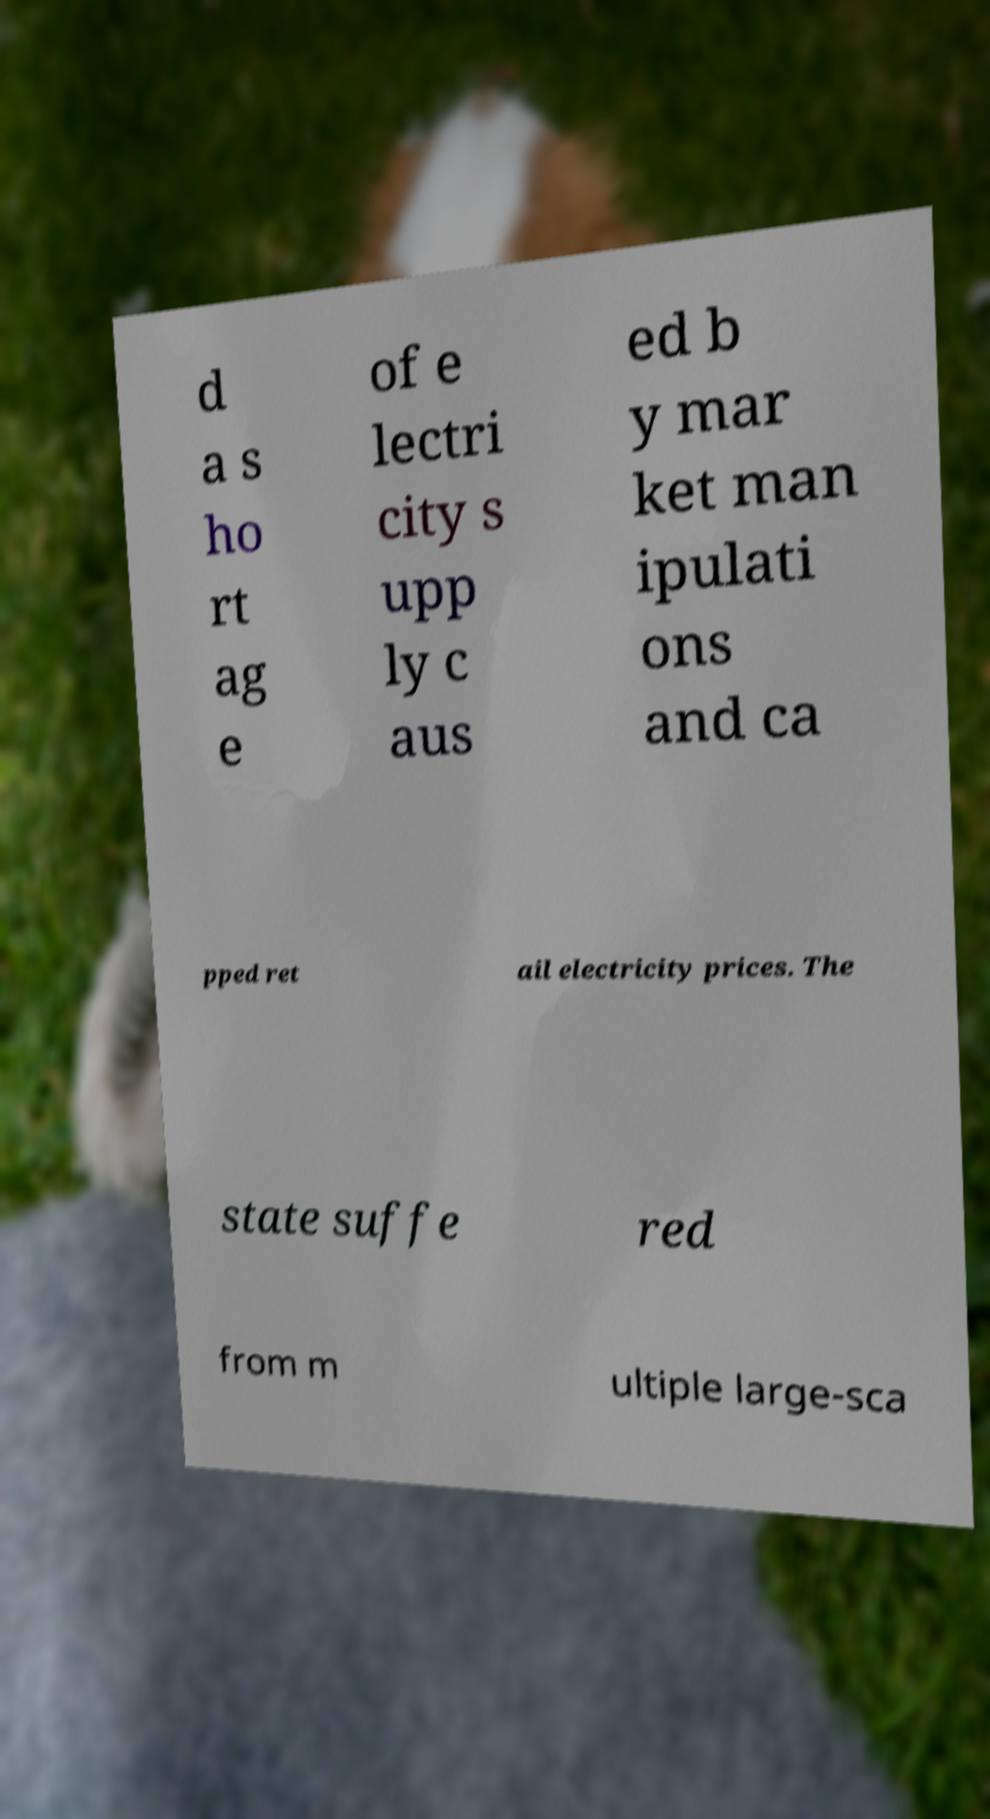What messages or text are displayed in this image? I need them in a readable, typed format. d a s ho rt ag e of e lectri city s upp ly c aus ed b y mar ket man ipulati ons and ca pped ret ail electricity prices. The state suffe red from m ultiple large-sca 